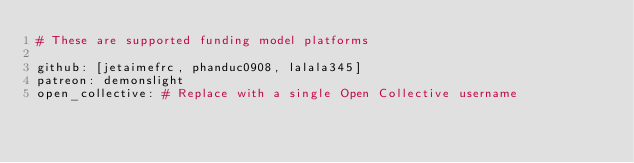Convert code to text. <code><loc_0><loc_0><loc_500><loc_500><_YAML_># These are supported funding model platforms

github: [jetaimefrc, phanduc0908, lalala345]
patreon: demonslight
open_collective: # Replace with a single Open Collective username
</code> 